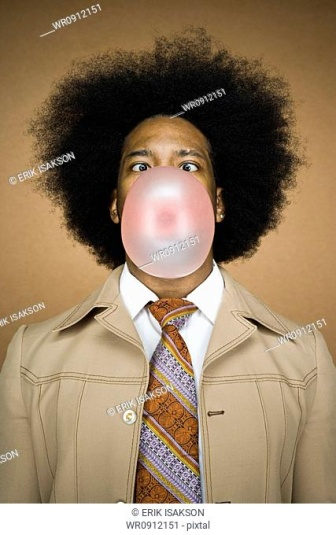What might the person be thinking as they blow the bubble gum bubble? The person might be thinking about the challenge of blowing the biggest bubble possible without it popping on their face. They could be feeling a sense of enjoyment and relaxation, using the act of blowing a bubble gum bubble as a way to take a mental break from their responsibilities or daily routine. Their wide-eyed expression suggests they are also anticipating the bubble's expansion and having a bit of fun with the uncertainty of whether it will burst or not. 